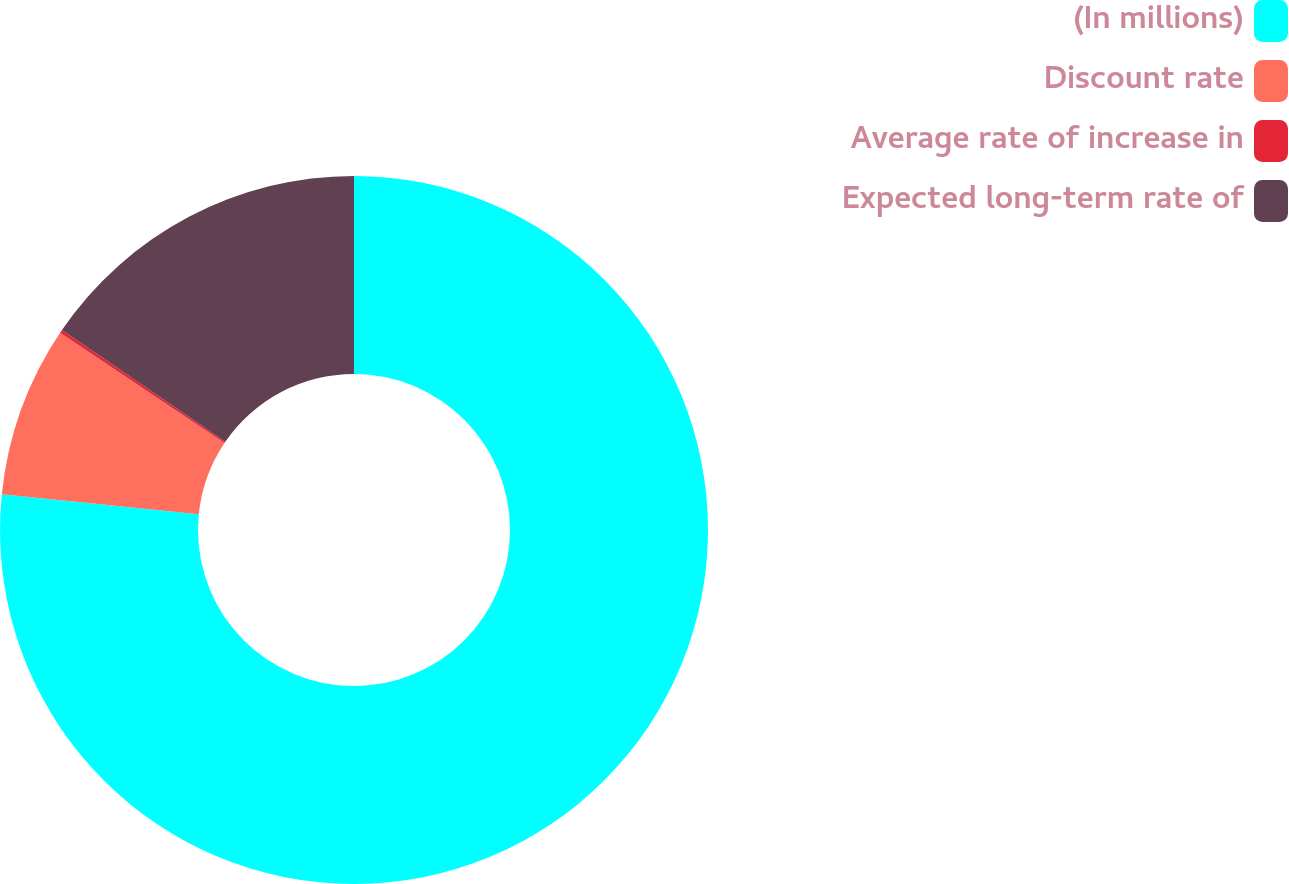<chart> <loc_0><loc_0><loc_500><loc_500><pie_chart><fcel>(In millions)<fcel>Discount rate<fcel>Average rate of increase in<fcel>Expected long-term rate of<nl><fcel>76.61%<fcel>7.8%<fcel>0.15%<fcel>15.44%<nl></chart> 